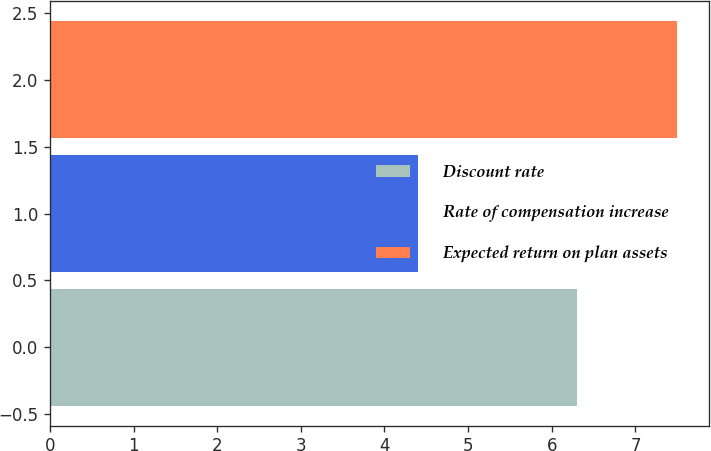Convert chart. <chart><loc_0><loc_0><loc_500><loc_500><bar_chart><fcel>Discount rate<fcel>Rate of compensation increase<fcel>Expected return on plan assets<nl><fcel>6.3<fcel>4.4<fcel>7.5<nl></chart> 